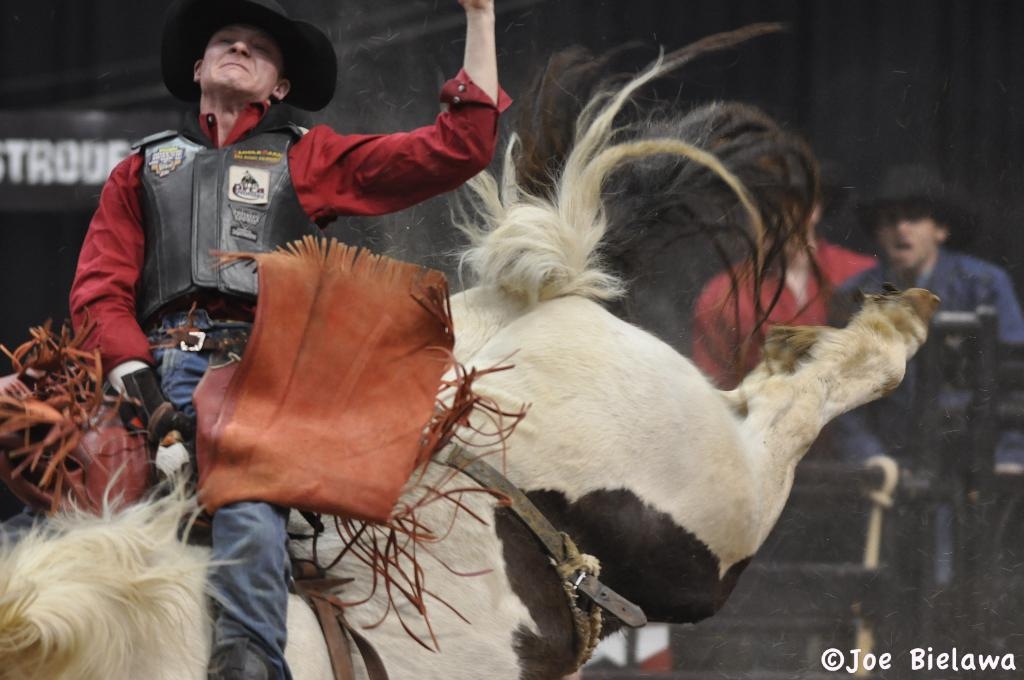What is the person in the image doing with the animal? The person is sitting on the animal and holding it. Are there any other people in the image besides the person sitting on the animal? Yes, there are two people standing at the back. What type of songs is the stove playing in the image? There is no stove or songs present in the image. 